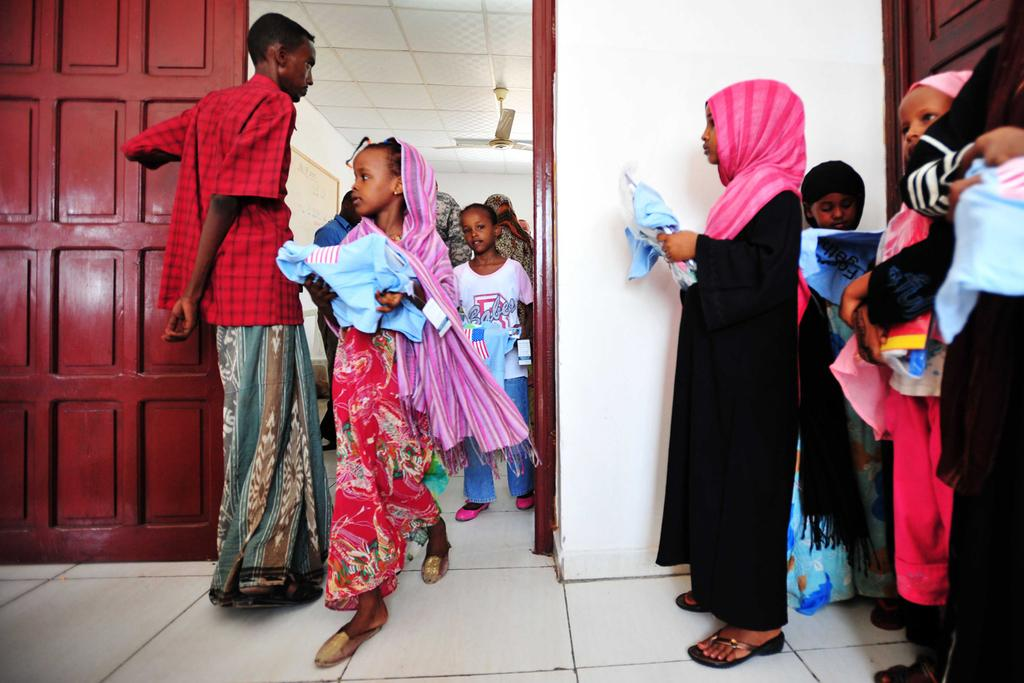What are the kids in the image holding? The kids in the image are holding objects. Can you describe the people in the image? There are people in the image, but their specific actions or characteristics are not mentioned in the facts. What architectural features can be seen in the image? There are doors in the image. What type of device is present in the image? There is a ceiling fan in the image. What other items can be seen in the image? There are other objects present in the image, but their specific nature is not mentioned in the facts. How many hearts can be seen in the image? There are no hearts visible in the image. What type of window is present in the image? There is no window mentioned in the facts, so it cannot be determined if there is one in the image. 